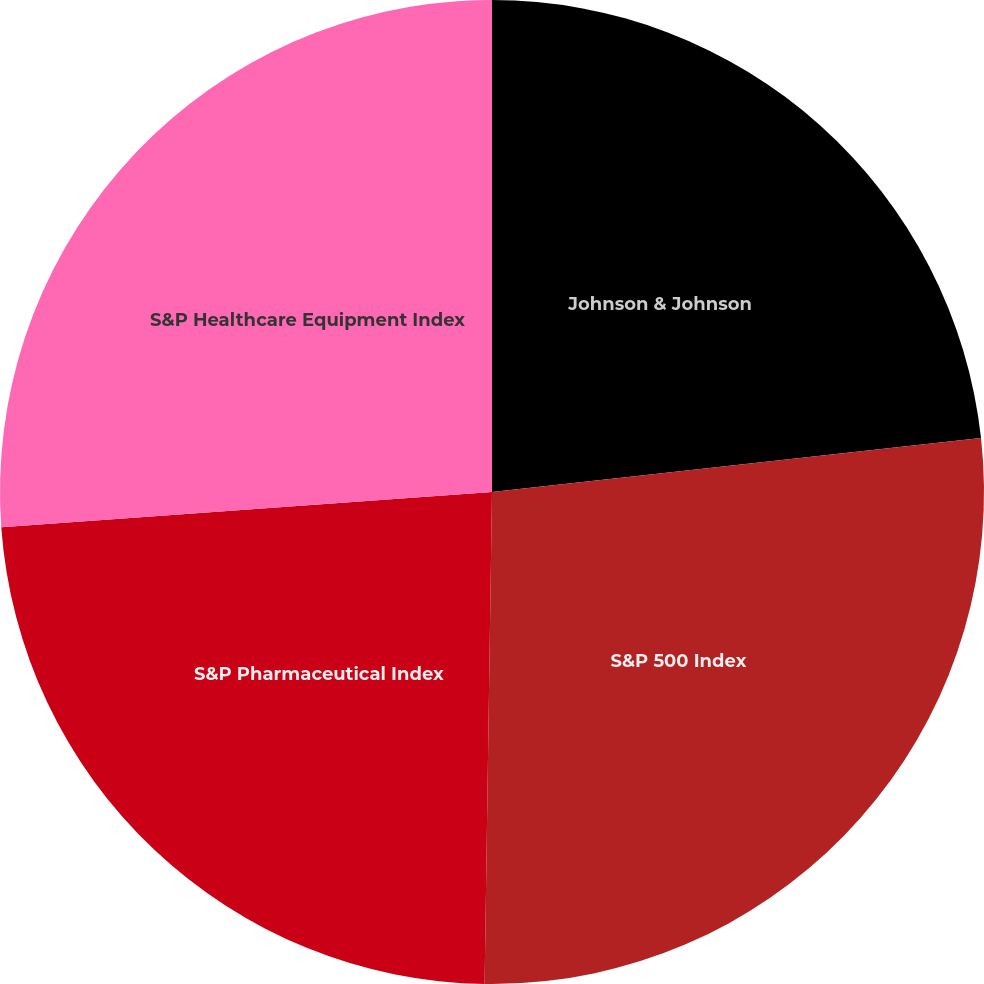Convert chart to OTSL. <chart><loc_0><loc_0><loc_500><loc_500><pie_chart><fcel>Johnson & Johnson<fcel>S&P 500 Index<fcel>S&P Pharmaceutical Index<fcel>S&P Healthcare Equipment Index<nl><fcel>23.25%<fcel>26.99%<fcel>23.62%<fcel>26.14%<nl></chart> 